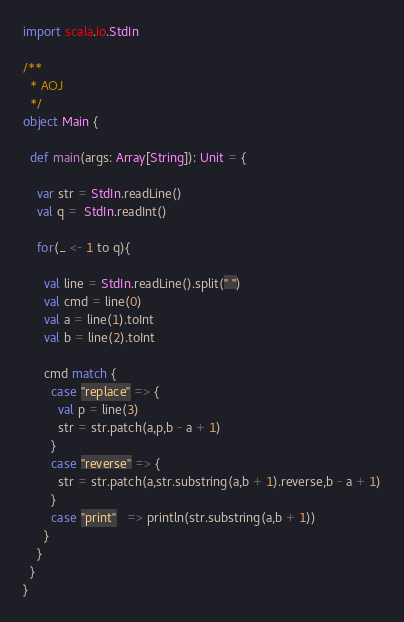Convert code to text. <code><loc_0><loc_0><loc_500><loc_500><_Scala_>import scala.io.StdIn

/**
  * AOJ
  */
object Main {

  def main(args: Array[String]): Unit = {

    var str = StdIn.readLine()
    val q =  StdIn.readInt()

    for(_ <- 1 to q){

      val line = StdIn.readLine().split(" ")
      val cmd = line(0)
      val a = line(1).toInt
      val b = line(2).toInt

      cmd match {
        case "replace" => {
          val p = line(3)
          str = str.patch(a,p,b - a + 1)
        }
        case "reverse" => {
          str = str.patch(a,str.substring(a,b + 1).reverse,b - a + 1)
        }
        case "print"   => println(str.substring(a,b + 1))
      }
    }
  }
}</code> 